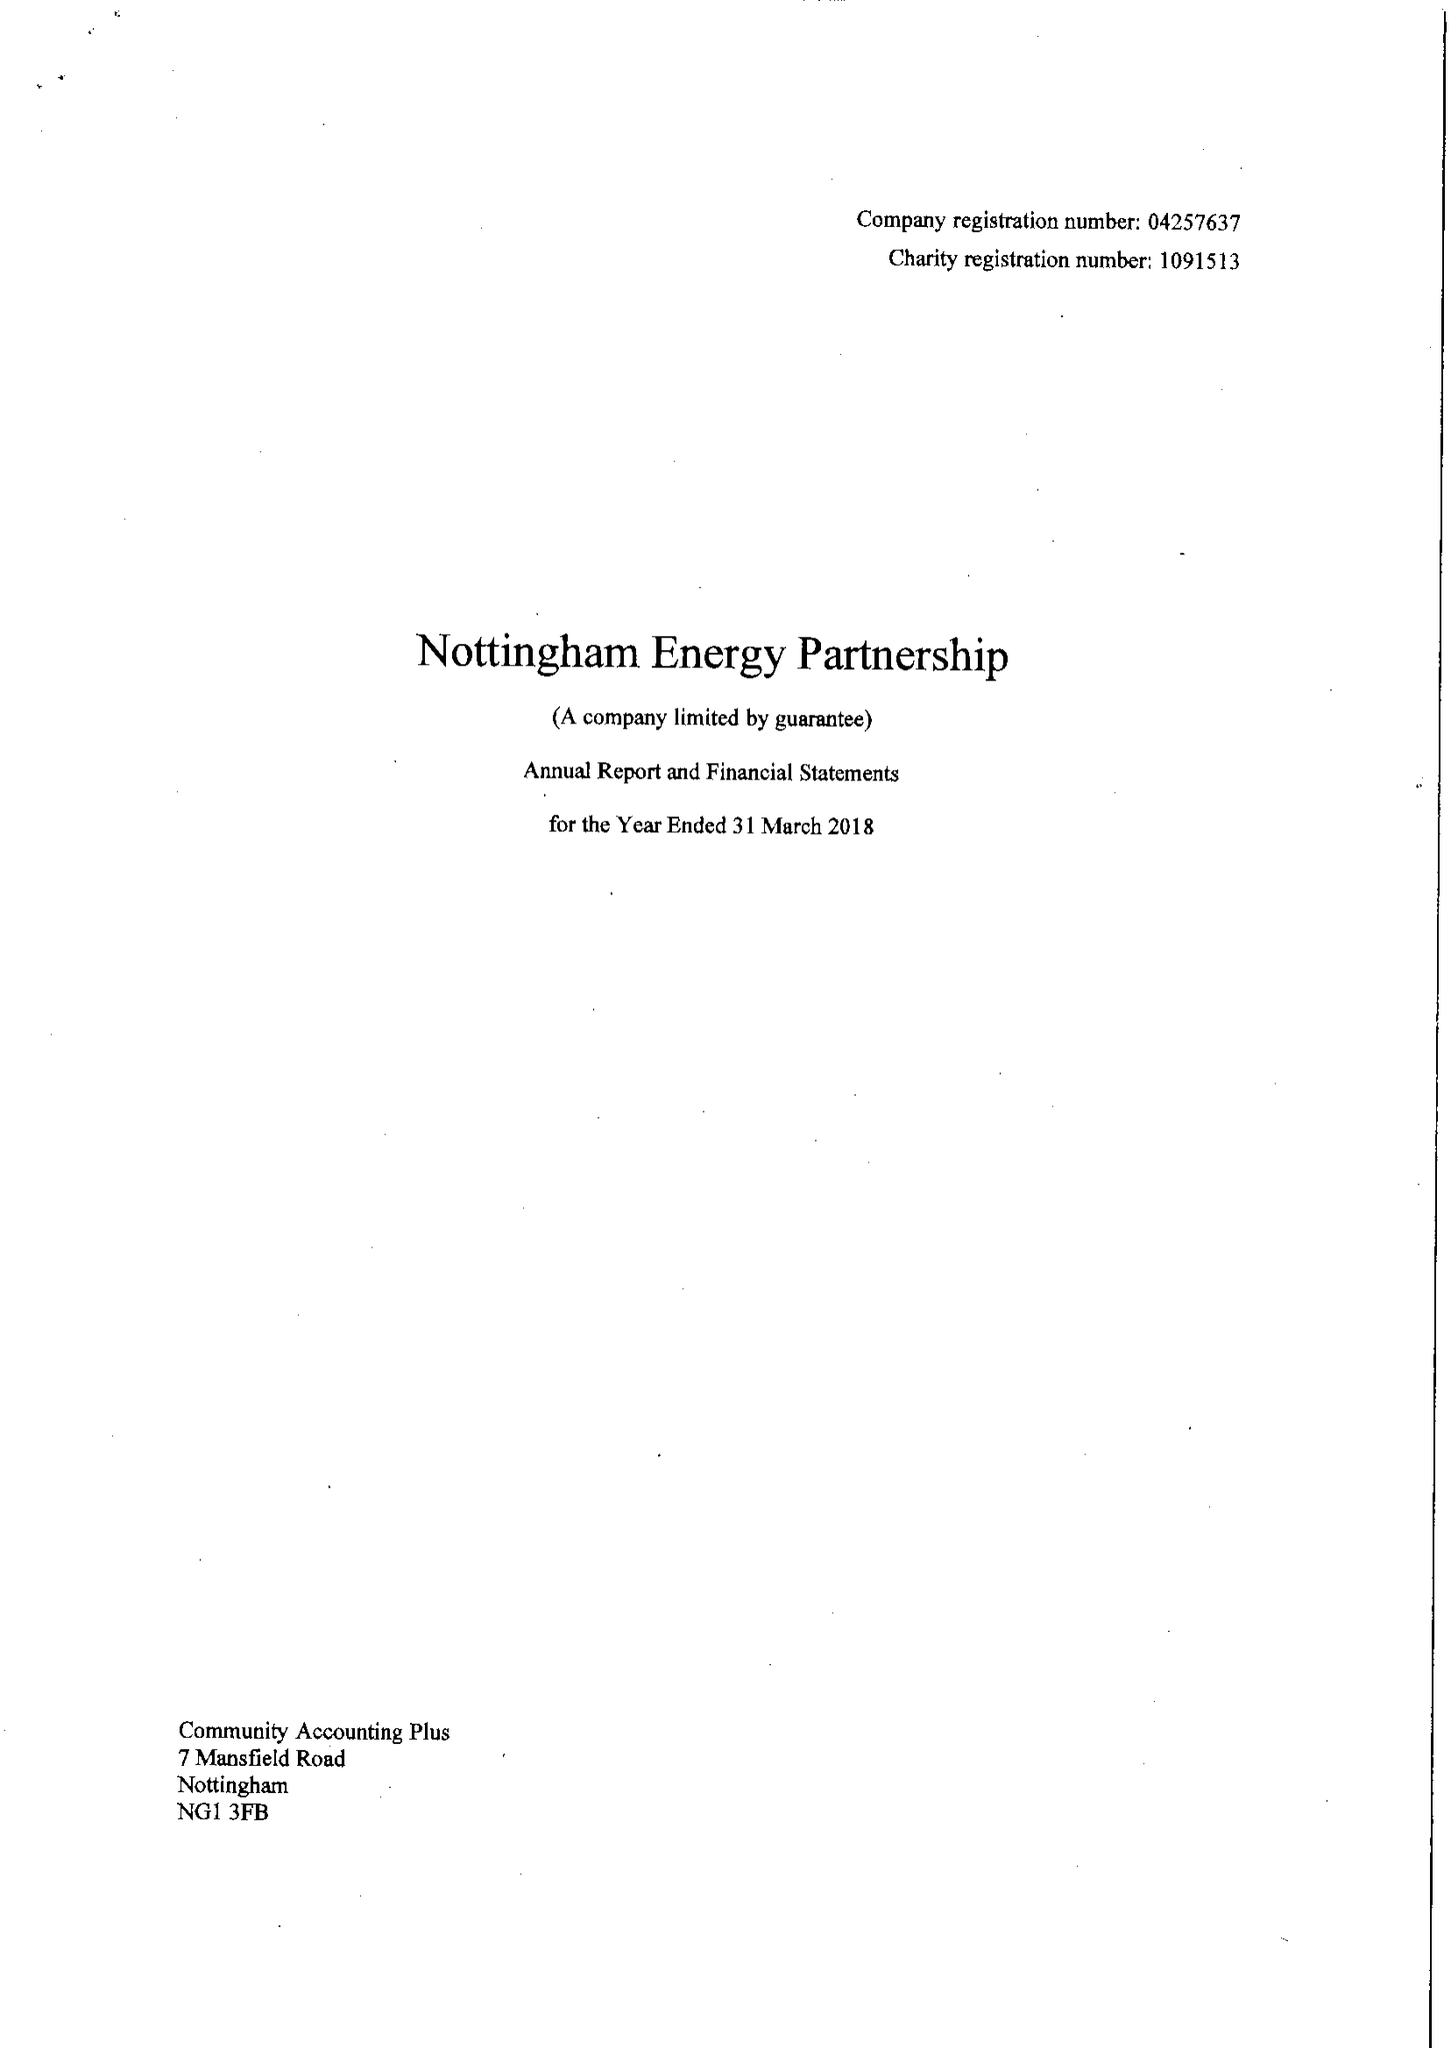What is the value for the income_annually_in_british_pounds?
Answer the question using a single word or phrase. 477345.00 